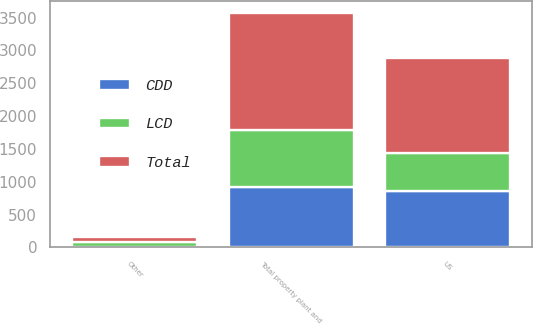Convert chart. <chart><loc_0><loc_0><loc_500><loc_500><stacked_bar_chart><ecel><fcel>US<fcel>Other<fcel>Total property plant and<nl><fcel>CDD<fcel>856.6<fcel>3.3<fcel>914.6<nl><fcel>LCD<fcel>587.1<fcel>77.5<fcel>870.1<nl><fcel>Total<fcel>1443.7<fcel>80.8<fcel>1784.7<nl></chart> 